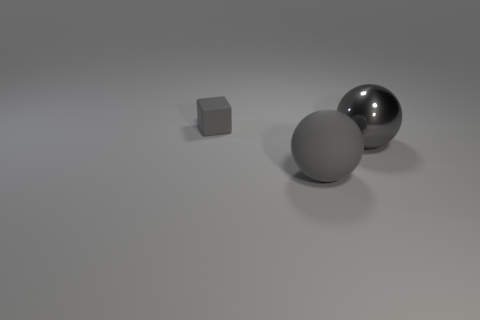Are there any other things that are the same size as the gray block?
Ensure brevity in your answer.  No. There is a gray thing that is behind the big matte sphere and in front of the tiny gray block; what is its shape?
Your answer should be compact. Sphere. What is the color of the matte object on the right side of the rubber cube?
Make the answer very short. Gray. Is there any other thing that has the same color as the small cube?
Provide a short and direct response. Yes. Is the gray matte sphere the same size as the gray metallic thing?
Your response must be concise. Yes. How big is the gray thing that is behind the large gray rubber ball and left of the shiny ball?
Keep it short and to the point. Small. What number of other gray blocks have the same material as the cube?
Ensure brevity in your answer.  0. There is a big object that is the same color as the metallic sphere; what is its shape?
Your answer should be compact. Sphere. There is a big gray thing that is behind the large rubber sphere; does it have the same shape as the large rubber thing?
Provide a succinct answer. Yes. How many things are either small gray rubber objects to the left of the shiny object or gray cubes?
Provide a succinct answer. 1. 